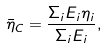Convert formula to latex. <formula><loc_0><loc_0><loc_500><loc_500>\bar { \eta } _ { C } = \frac { \Sigma _ { i } E _ { i } \eta _ { i } } { \Sigma _ { i } E _ { i } } ,</formula> 